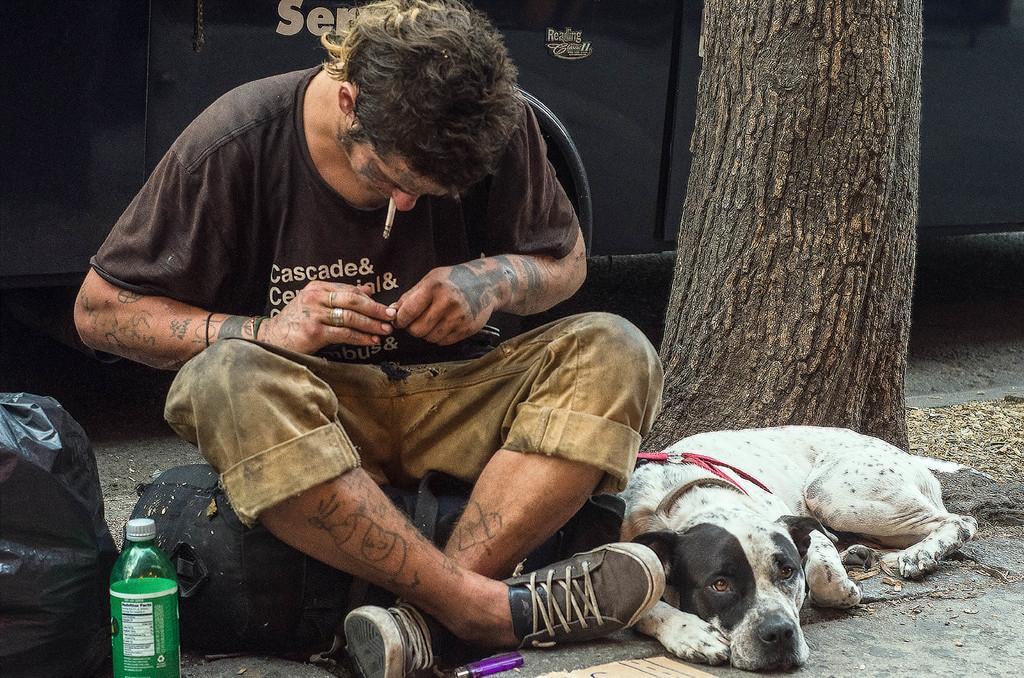Please provide a concise description of this image. As we can see in the image there is a tree stem, dog and a man sitting over here. On the left side there is a black color cover and a bottle. 